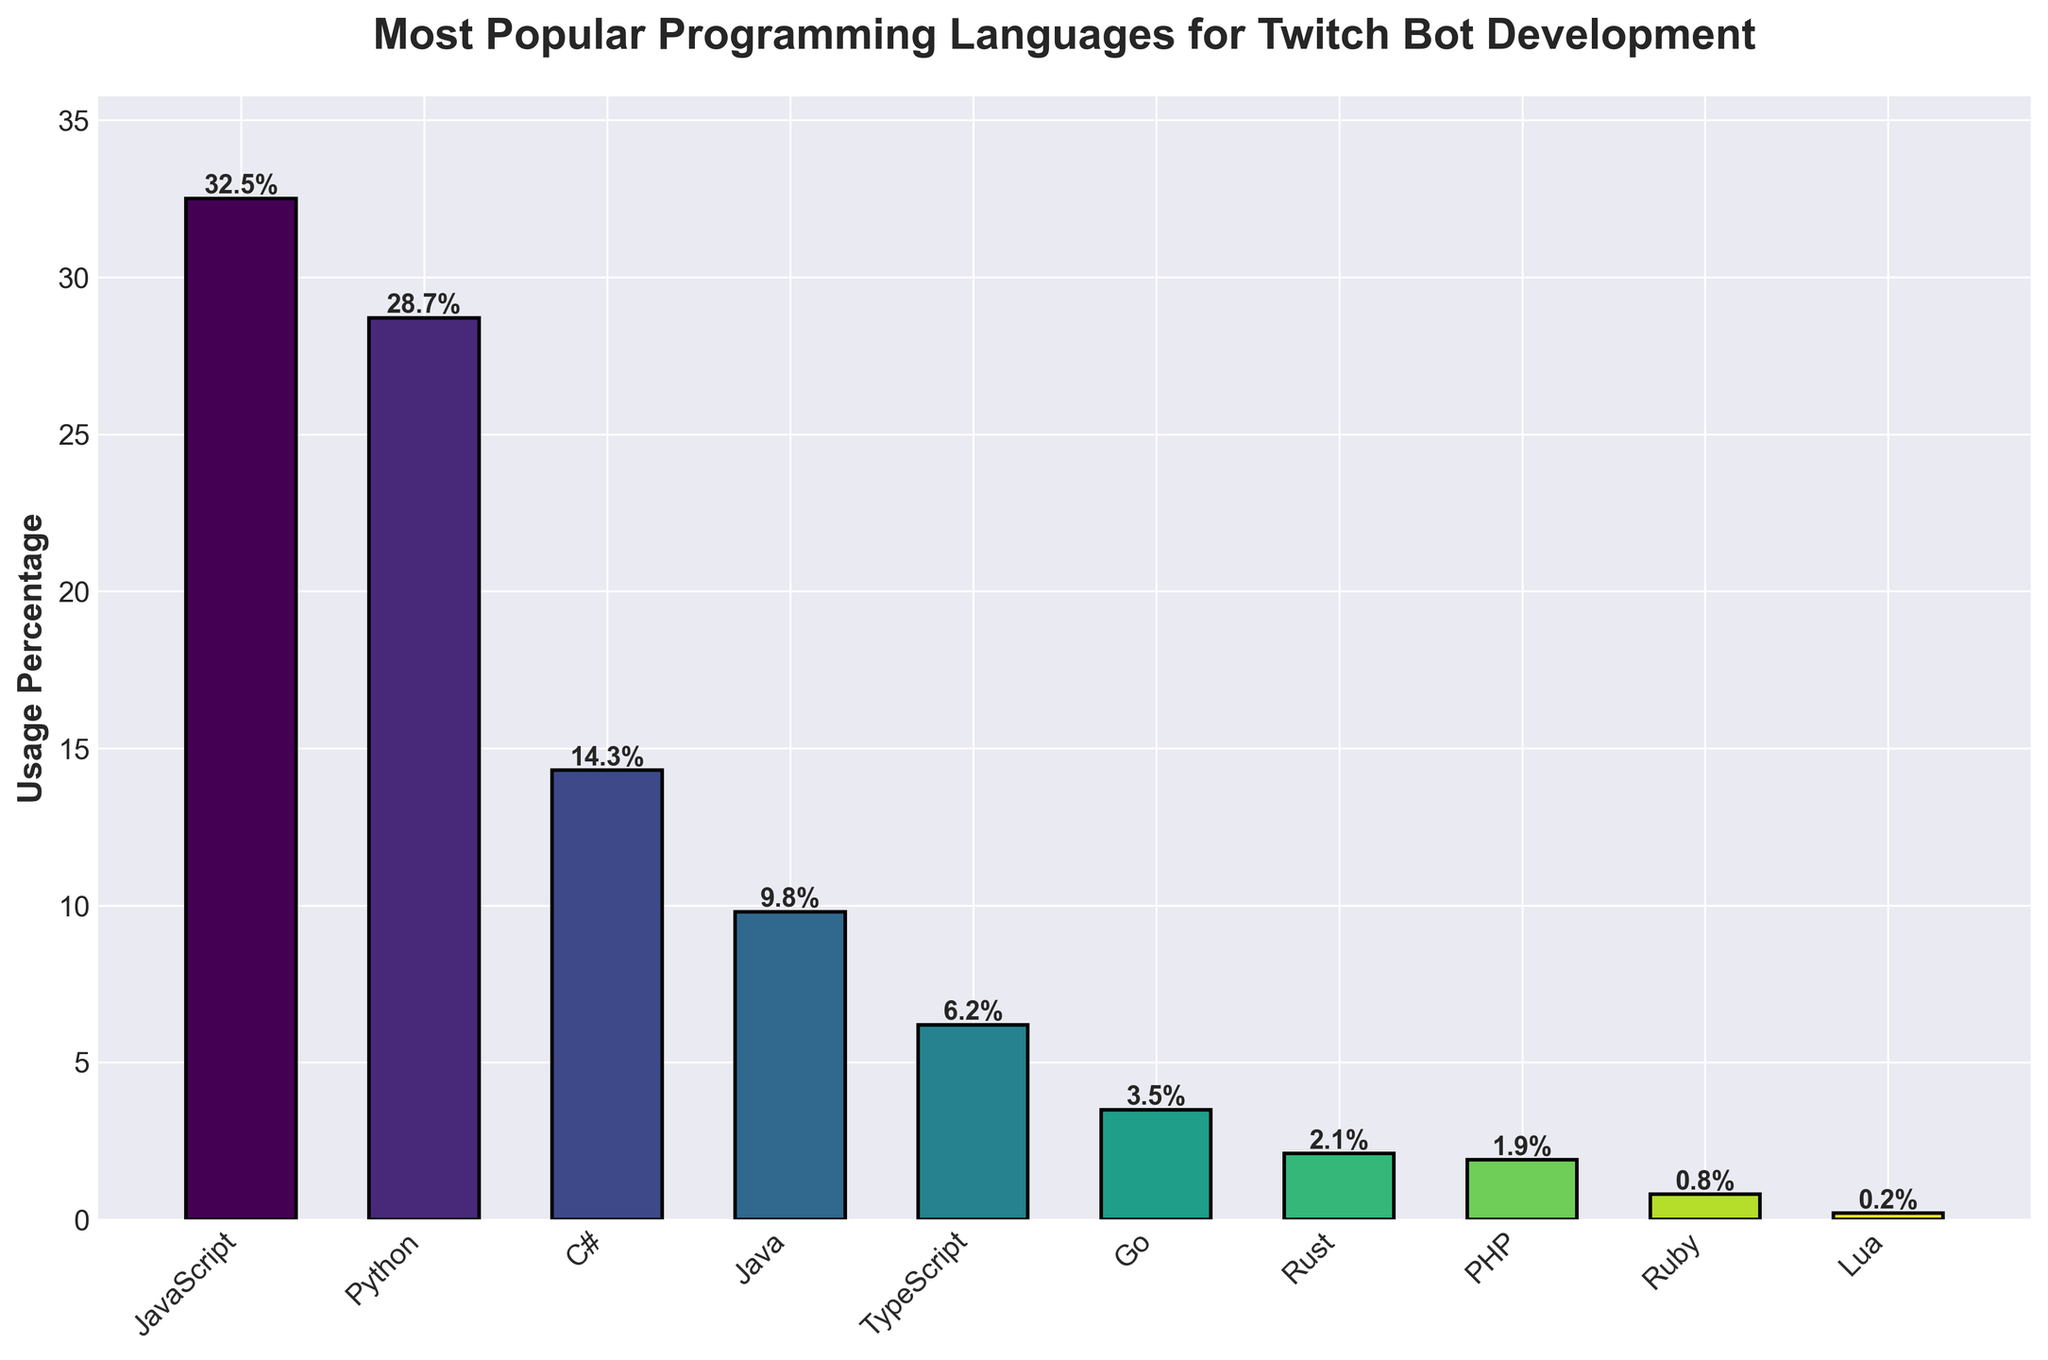Which programming language has the highest usage percentage in Twitch bot development? By looking at the highest bar in the figure, we can see that JavaScript is the language with the highest usage percentage.
Answer: JavaScript How much greater is JavaScript's usage percentage compared to Python's? JavaScript's usage percentage is 32.5%, and Python's is 28.7%. Subtracting these values gives the difference: 32.5 - 28.7 = 3.8.
Answer: 3.8% Which two languages have the smallest usage percentages, and what are their values? The smallest bars in the figure represent Lua and Ruby, with usage percentages of 0.2% and 0.8%, respectively.
Answer: Lua and Ruby (0.2% and 0.8%) Calculate the total usage percentage of the three least used languages. The three least used languages are Lua (0.2%), Ruby (0.8%), and PHP (1.9%). Adding these values together gives: 0.2 + 0.8 + 1.9 = 2.9%.
Answer: 2.9% Which language, out of Java and TypeScript, is used more, and by how much? Java's usage percentage is 9.8%, and TypeScript's is 6.2%. The difference is 9.8 - 6.2 = 3.6%.
Answer: Java by 3.6% What is the combined usage percentage of the top two languages? The top two languages are JavaScript (32.5%) and Python (28.7%). Their combined usage percentage is 32.5 + 28.7 = 61.2%.
Answer: 61.2% Visually, which bar is closest in height to the 10% mark? The bar for Java, with a usage percentage of 9.8%, is closest in height to the 10% mark.
Answer: Java Compare the usage percentage of C# to Go and state which is higher and by what percentage. C# has a usage percentage of 14.3% while Go has 3.5%. The difference is 14.3 - 3.5 = 10.8%.
Answer: C# by 10.8% What percentage of the total usage does Rust and PHP together represent? Rust has 2.1% and PHP has 1.9% usage. Together, they represent 2.1 + 1.9 = 4.0% of the total usage.
Answer: 4.0% Identify the color of the bar for Python. The bar for Python can be identified by its position as the second from the left and is colored in the gradient scheme used, which tends to have a darker green tint compared to the light-colored JavaScript bar.
Answer: Dark green 